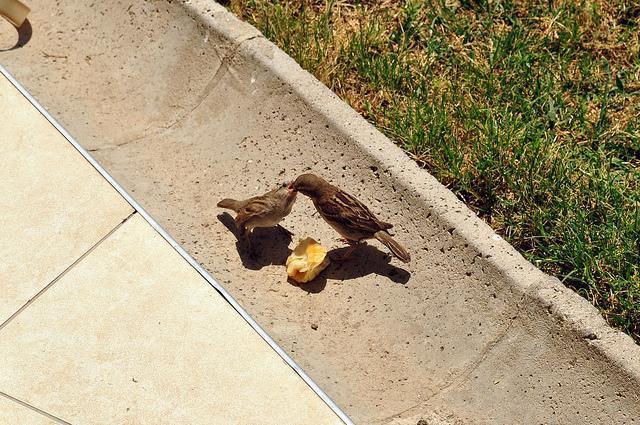How many birds are there?
Give a very brief answer. 2. How many men are wearing the number eighteen on their jersey?
Give a very brief answer. 0. 